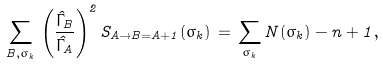Convert formula to latex. <formula><loc_0><loc_0><loc_500><loc_500>\sum _ { { B } , \sigma _ { k } } \, \left ( \frac { \hat { \Gamma } _ { B } } { \hat { \Gamma } _ { A } } \right ) ^ { 2 } S _ { A \rightarrow B = A + 1 } ( \sigma _ { k } ) \, = \, \sum _ { \sigma _ { k } } N ( \sigma _ { k } ) - n + 1 ,</formula> 